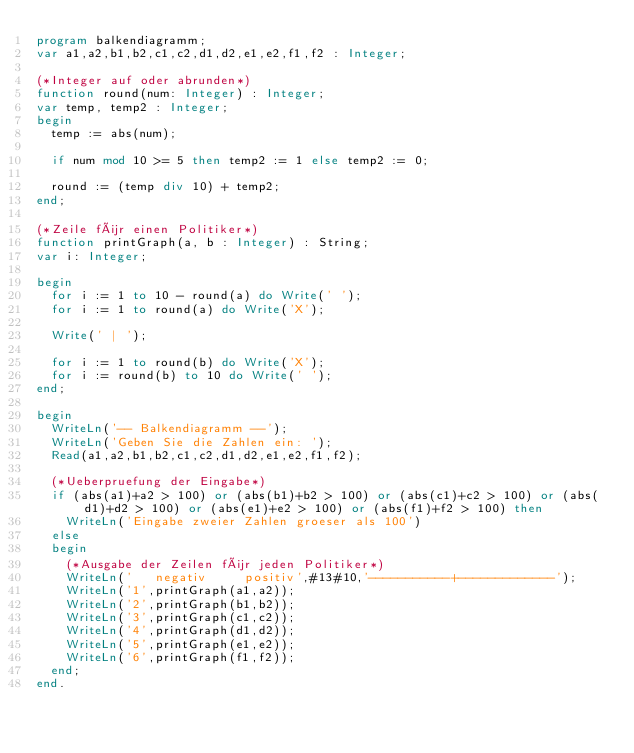Convert code to text. <code><loc_0><loc_0><loc_500><loc_500><_Pascal_>program balkendiagramm;
var a1,a2,b1,b2,c1,c2,d1,d2,e1,e2,f1,f2 : Integer;

(*Integer auf oder abrunden*)
function round(num: Integer) : Integer;
var temp, temp2 : Integer;
begin
  temp := abs(num);
  
  if num mod 10 >= 5 then temp2 := 1 else temp2 := 0;
  
  round := (temp div 10) + temp2;
end;

(*Zeile für einen Politiker*)
function printGraph(a, b : Integer) : String;
var i: Integer;

begin
  for i := 1 to 10 - round(a) do Write(' ');
  for i := 1 to round(a) do Write('X');
  
  Write(' | ');

  for i := 1 to round(b) do Write('X');
  for i := round(b) to 10 do Write(' ');   
end;

begin
  WriteLn('-- Balkendiagramm --');
  WriteLn('Geben Sie die Zahlen ein: ');
  Read(a1,a2,b1,b2,c1,c2,d1,d2,e1,e2,f1,f2);

  (*Ueberpruefung der Eingabe*)
  if (abs(a1)+a2 > 100) or (abs(b1)+b2 > 100) or (abs(c1)+c2 > 100) or (abs(d1)+d2 > 100) or (abs(e1)+e2 > 100) or (abs(f1)+f2 > 100) then
    WriteLn('Eingabe zweier Zahlen groeser als 100')
  else
  begin
    (*Ausgabe der Zeilen für jeden Politiker*)
    WriteLn('   negativ     positiv',#13#10,'-----------+-------------');
    WriteLn('1',printGraph(a1,a2));
    WriteLn('2',printGraph(b1,b2));
    WriteLn('3',printGraph(c1,c2));
    WriteLn('4',printGraph(d1,d2));
    WriteLn('5',printGraph(e1,e2));
    WriteLn('6',printGraph(f1,f2));
  end;
end.  </code> 